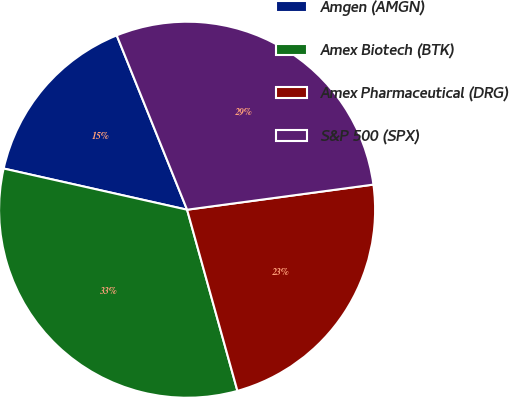<chart> <loc_0><loc_0><loc_500><loc_500><pie_chart><fcel>Amgen (AMGN)<fcel>Amex Biotech (BTK)<fcel>Amex Pharmaceutical (DRG)<fcel>S&P 500 (SPX)<nl><fcel>15.38%<fcel>32.83%<fcel>22.82%<fcel>28.97%<nl></chart> 